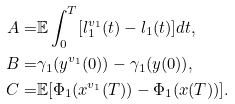Convert formula to latex. <formula><loc_0><loc_0><loc_500><loc_500>A = & \mathbb { E } \int _ { 0 } ^ { T } [ l _ { 1 } ^ { v _ { 1 } } ( t ) - l _ { 1 } ( t ) ] d t , \\ B = & \gamma _ { 1 } ( y ^ { v _ { 1 } } ( 0 ) ) - \gamma _ { 1 } ( y ( 0 ) ) , \\ C = & \mathbb { E } [ \Phi _ { 1 } ( x ^ { v _ { 1 } } ( T ) ) - \Phi _ { 1 } ( x ( T ) ) ] .</formula> 